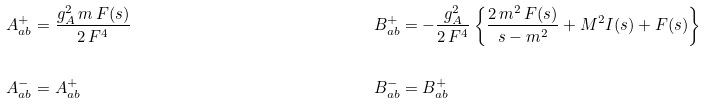<formula> <loc_0><loc_0><loc_500><loc_500>A ^ { + } _ { a b } & = \frac { g _ { A } ^ { 2 } \, m \, F ( s ) } { 2 \, F ^ { 4 } } & B ^ { + } _ { a b } & = - \frac { g _ { A } ^ { 2 } } { 2 \, F ^ { 4 } } \left \{ { \frac { 2 \, m ^ { 2 } \, F ( s ) } { s - m ^ { 2 } } } + M ^ { 2 } I ( s ) + F ( s ) \right \} \\ & & \\ A ^ { - } _ { a b } & = A ^ { + } _ { a b } & B ^ { - } _ { a b } & = B ^ { + } _ { a b }</formula> 